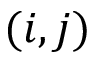Convert formula to latex. <formula><loc_0><loc_0><loc_500><loc_500>( i , j )</formula> 